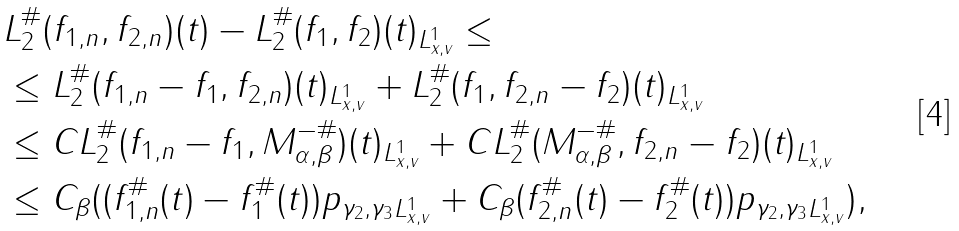<formula> <loc_0><loc_0><loc_500><loc_500>\| & L _ { 2 } ^ { \# } ( f _ { 1 , n } , f _ { 2 , n } ) ( t ) - L _ { 2 } ^ { \# } ( f _ { 1 } , f _ { 2 } ) ( t ) \| _ { L ^ { 1 } _ { x , v } } \leq \\ & \leq \| L _ { 2 } ^ { \# } ( f _ { 1 , n } - f _ { 1 } , f _ { 2 , n } ) ( t ) \| _ { L ^ { 1 } _ { x , v } } + \| L _ { 2 } ^ { \# } ( f _ { 1 } , f _ { 2 , n } - f _ { 2 } ) ( t ) \| _ { L ^ { 1 } _ { x , v } } \\ & \leq C \| L _ { 2 } ^ { \# } ( f _ { 1 , n } - f _ { 1 } , M _ { \alpha , \beta } ^ { - \# } ) ( t ) \| _ { L ^ { 1 } _ { x , v } } + C \| L _ { 2 } ^ { \# } ( M _ { \alpha , \beta } ^ { - \# } , f _ { 2 , n } - f _ { 2 } ) ( t ) \| _ { L ^ { 1 } _ { x , v } } \\ & \leq C _ { \beta } ( \| ( f _ { 1 , n } ^ { \# } ( t ) - f _ { 1 } ^ { \# } ( t ) ) p _ { \gamma _ { 2 } , \gamma _ { 3 } } \| _ { L ^ { 1 } _ { x , v } } + C _ { \beta } \| ( f _ { 2 , n } ^ { \# } ( t ) - f _ { 2 } ^ { \# } ( t ) ) p _ { \gamma _ { 2 } , \gamma _ { 3 } } \| _ { L ^ { 1 } _ { x , v } } ) ,</formula> 